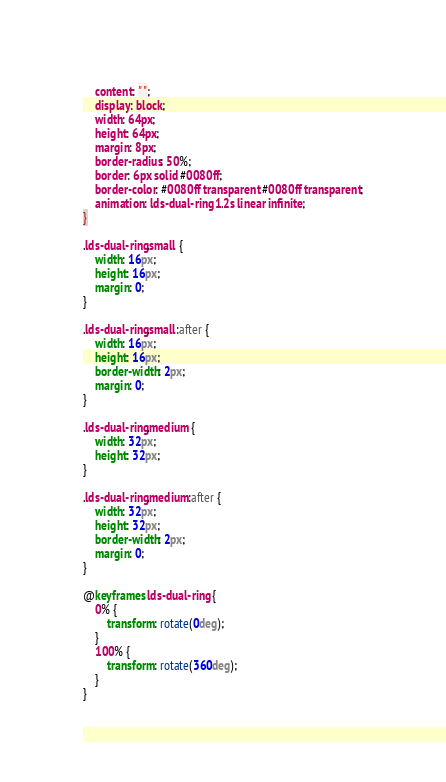<code> <loc_0><loc_0><loc_500><loc_500><_CSS_>    content: " ";
    display: block;
    width: 64px;
    height: 64px;
    margin: 8px;
    border-radius: 50%;
    border: 6px solid #0080ff;
    border-color: #0080ff transparent #0080ff transparent;
    animation: lds-dual-ring 1.2s linear infinite;
}

.lds-dual-ring.small {
    width: 16px;
    height: 16px;
    margin: 0;
}

.lds-dual-ring.small:after {
    width: 16px;
    height: 16px;
    border-width: 2px;
    margin: 0;
}

.lds-dual-ring.medium {
    width: 32px;
    height: 32px;
}

.lds-dual-ring.medium:after {
    width: 32px;
    height: 32px;
    border-width: 2px;
    margin: 0;
}

@keyframes lds-dual-ring {
    0% {
        transform: rotate(0deg);
    }
    100% {
        transform: rotate(360deg);
    }
}
</code> 